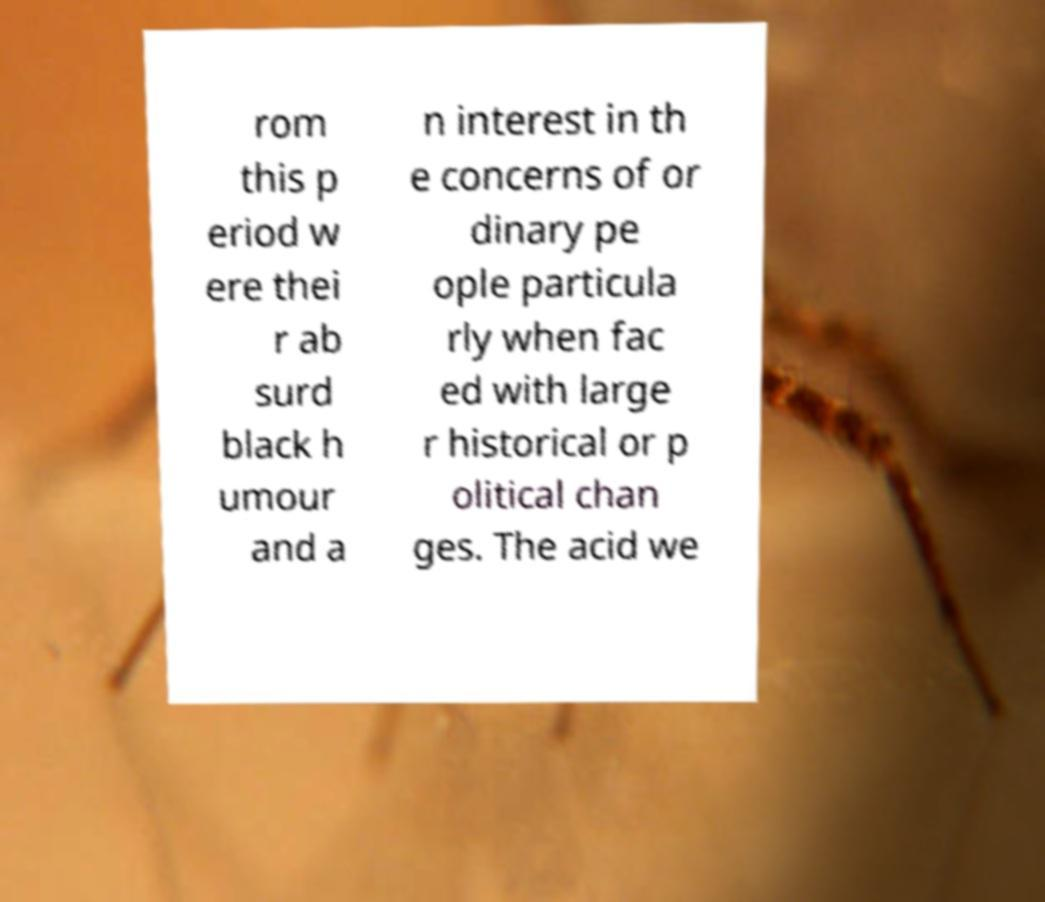Can you accurately transcribe the text from the provided image for me? rom this p eriod w ere thei r ab surd black h umour and a n interest in th e concerns of or dinary pe ople particula rly when fac ed with large r historical or p olitical chan ges. The acid we 